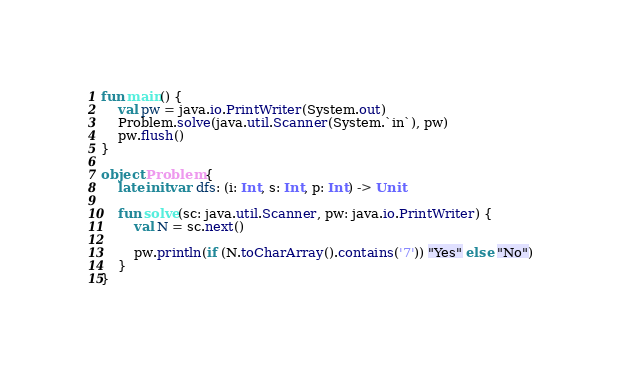<code> <loc_0><loc_0><loc_500><loc_500><_Kotlin_>fun main() {
    val pw = java.io.PrintWriter(System.out)
    Problem.solve(java.util.Scanner(System.`in`), pw)
    pw.flush()
}

object Problem {
    lateinit var dfs: (i: Int, s: Int, p: Int) -> Unit

    fun solve(sc: java.util.Scanner, pw: java.io.PrintWriter) {
        val N = sc.next()

        pw.println(if (N.toCharArray().contains('7')) "Yes" else "No")
    }
}
</code> 